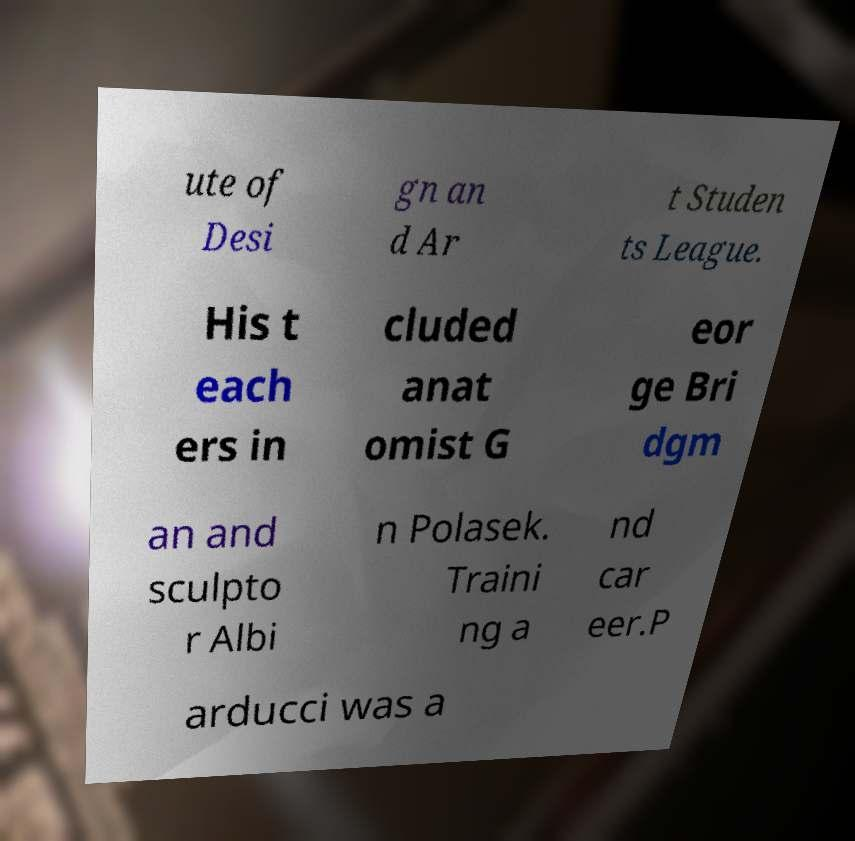Could you extract and type out the text from this image? ute of Desi gn an d Ar t Studen ts League. His t each ers in cluded anat omist G eor ge Bri dgm an and sculpto r Albi n Polasek. Traini ng a nd car eer.P arducci was a 